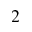<formula> <loc_0><loc_0><loc_500><loc_500>^ { 2 }</formula> 